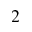<formula> <loc_0><loc_0><loc_500><loc_500>^ { 2 }</formula> 